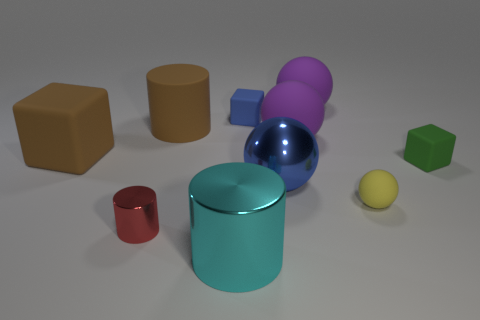Subtract all tiny spheres. How many spheres are left? 3 Subtract all brown cylinders. How many purple spheres are left? 2 Subtract 3 balls. How many balls are left? 1 Subtract all green cubes. How many cubes are left? 2 Add 2 small blue rubber blocks. How many small blue rubber blocks are left? 3 Add 3 big matte cylinders. How many big matte cylinders exist? 4 Subtract 1 brown blocks. How many objects are left? 9 Subtract all blocks. How many objects are left? 7 Subtract all blue cylinders. Subtract all red balls. How many cylinders are left? 3 Subtract all balls. Subtract all brown objects. How many objects are left? 4 